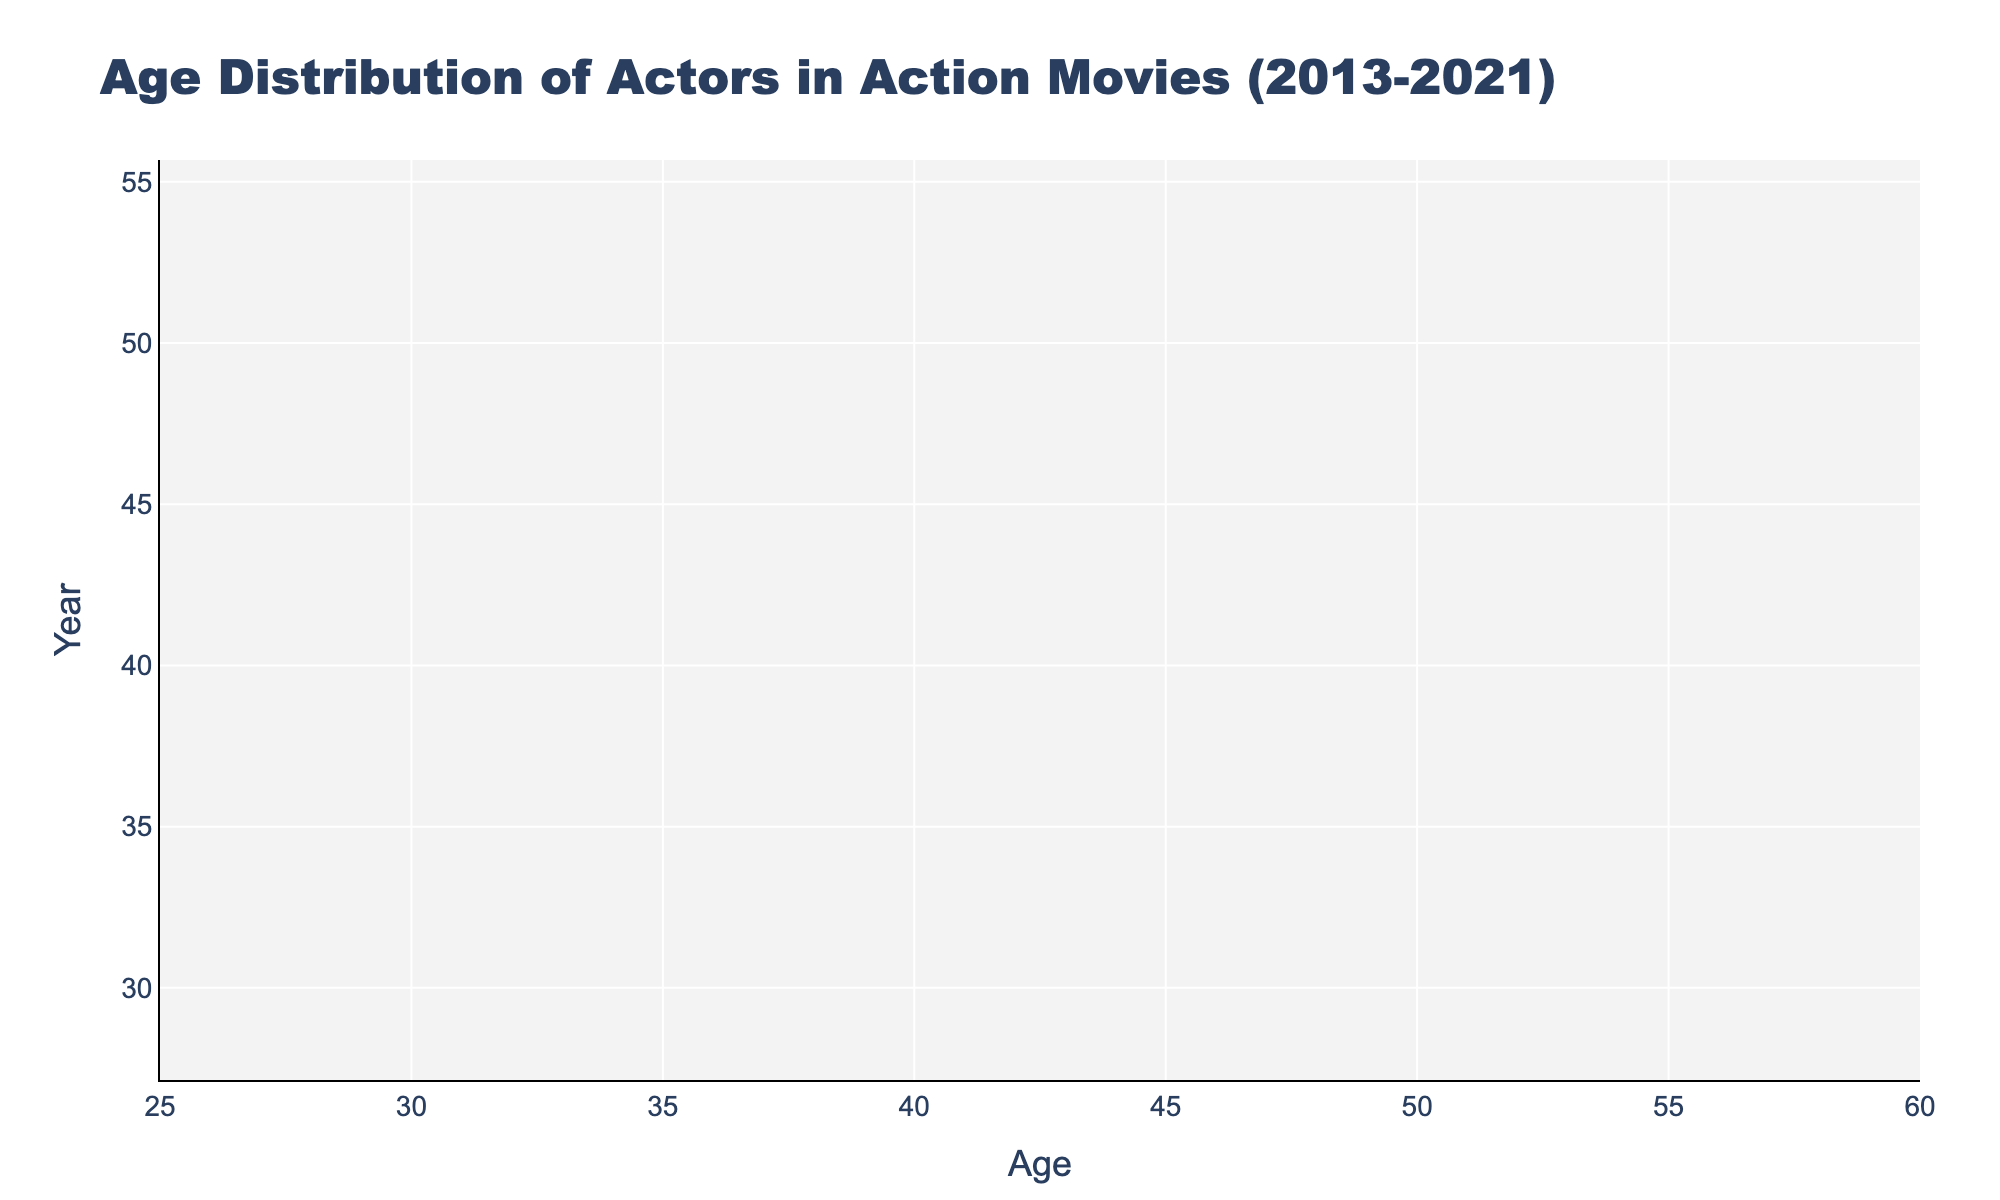what is the title of the plot? The title is located at the top of the plot. It is meant to give a brief summary of the main subject of the chart.
Answer: Age Distribution of Actors in Action Movies (2013-2021) What is the age range displayed on the x-axis? The x-axis shows the age range of the actors, and it is marked with tick marks and labels to indicate the range.
Answer: 25 to 60 How many years are covered in the dataset? Each violin plot represents data for a specific year. By counting the number of violin plots, we can determine the number of years covered.
Answer: 9 Which year features the youngest actor? By comparing the lower end of each violin plot, we can identify which year has the lowest age value.
Answer: 2019 Which year has the widest age range? To determine this, we need to look at the spread of ages in each violin plot and identify which one has the largest gap between the highest and lowest ages.
Answer: 2019 Are all the years represented by the violin plots filled with the same color? Observing the colors of each violin plot can quickly determine if all have the same or different fill colors.
Answer: No What is the mean age of actors in the year 2020? Mean age is often marked by a line or dot within the violin plot. For the year 2020, find the central tendency marker.
Answer: Approximately 39-40 Is there any year without a data point above the age of 50? Check each violin plot to see if there are any that do not extend beyond the age of 50.
Answer: Yes, 2021 What year shows the most actors around the age of 34? Look for the density of data points around 34 across different violin plots to determine which year has the highest concentration around that age.
Answer: 2020 